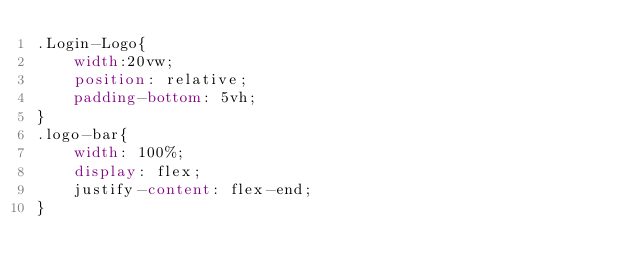Convert code to text. <code><loc_0><loc_0><loc_500><loc_500><_CSS_>.Login-Logo{
    width:20vw;
    position: relative;
    padding-bottom: 5vh;
}
.logo-bar{
    width: 100%;
    display: flex;
    justify-content: flex-end;
}</code> 